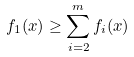Convert formula to latex. <formula><loc_0><loc_0><loc_500><loc_500>f _ { 1 } ( x ) \geq \sum _ { i = 2 } ^ { m } f _ { i } ( x )</formula> 